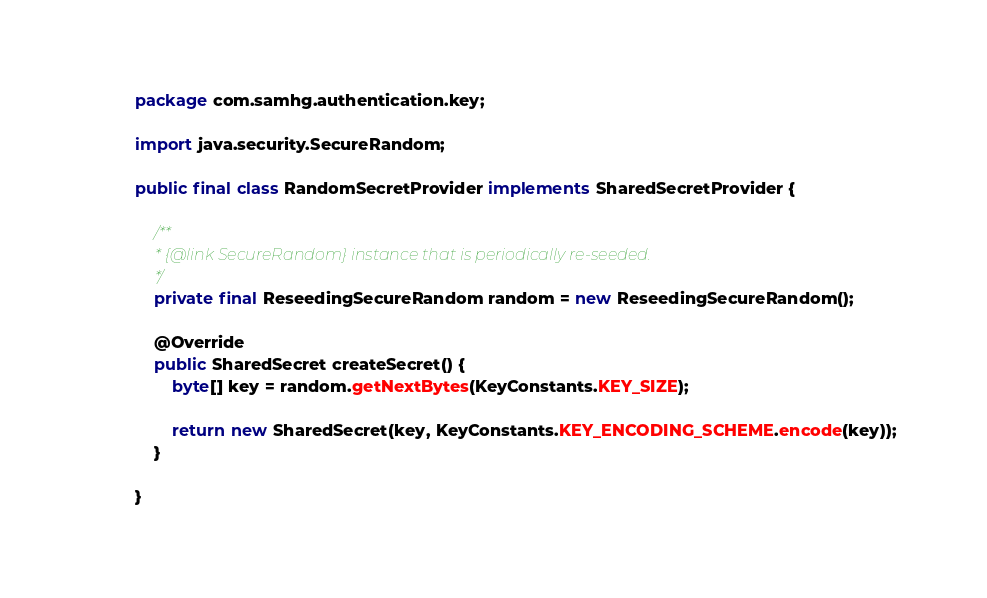<code> <loc_0><loc_0><loc_500><loc_500><_Java_>package com.samhg.authentication.key;

import java.security.SecureRandom;

public final class RandomSecretProvider implements SharedSecretProvider {

	/**
	 * {@link SecureRandom} instance that is periodically re-seeded.
	 */
	private final ReseedingSecureRandom random = new ReseedingSecureRandom();
	
	@Override
	public SharedSecret createSecret() {
		byte[] key = random.getNextBytes(KeyConstants.KEY_SIZE);

		return new SharedSecret(key, KeyConstants.KEY_ENCODING_SCHEME.encode(key));
	}

}</code> 